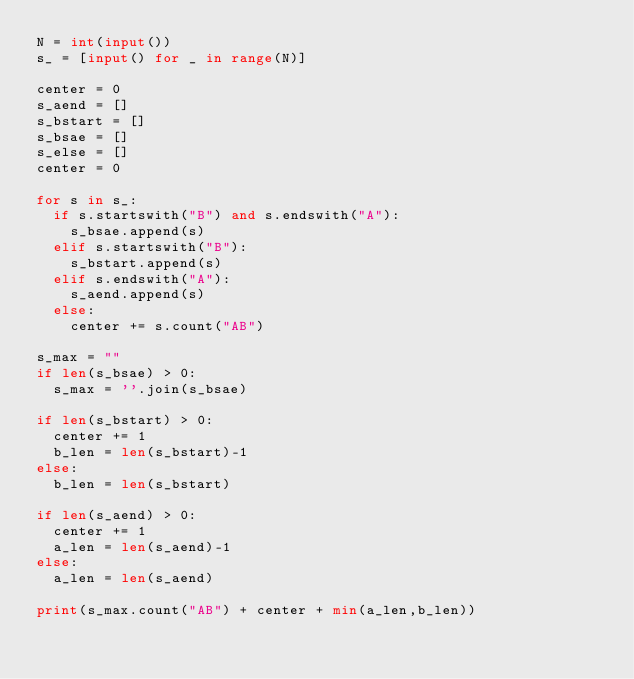Convert code to text. <code><loc_0><loc_0><loc_500><loc_500><_Python_>N = int(input())
s_ = [input() for _ in range(N)]

center = 0
s_aend = []
s_bstart = []
s_bsae = []
s_else = []
center = 0

for s in s_:
  if s.startswith("B") and s.endswith("A"):
    s_bsae.append(s)
  elif s.startswith("B"):
    s_bstart.append(s)
  elif s.endswith("A"):
    s_aend.append(s)
  else:
    center += s.count("AB")

s_max = ""
if len(s_bsae) > 0:
  s_max = ''.join(s_bsae)

if len(s_bstart) > 0:
  center += 1
  b_len = len(s_bstart)-1
else:
  b_len = len(s_bstart)
  
if len(s_aend) > 0:
  center += 1
  a_len = len(s_aend)-1
else:
  a_len = len(s_aend)
  
print(s_max.count("AB") + center + min(a_len,b_len))




</code> 